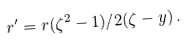Convert formula to latex. <formula><loc_0><loc_0><loc_500><loc_500>r ^ { \prime } = r ( \zeta ^ { 2 } - 1 ) / 2 ( \zeta - y ) \, .</formula> 